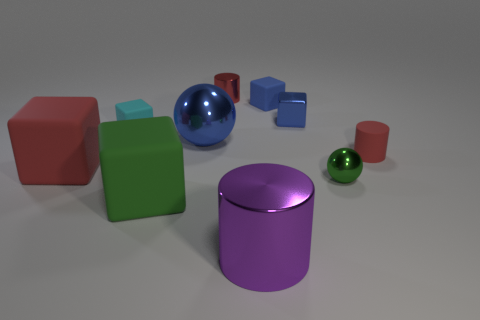There is a red rubber object behind the large rubber object that is on the left side of the green rubber block; what number of small cyan rubber blocks are to the left of it?
Your answer should be very brief. 1. There is a ball that is made of the same material as the small green object; what is its color?
Give a very brief answer. Blue. There is a sphere that is left of the purple cylinder; is its size the same as the tiny red rubber thing?
Offer a very short reply. No. What number of things are large metal cylinders or small cyan things?
Make the answer very short. 2. What material is the small red thing behind the small matte block to the right of the cube that is in front of the green shiny ball?
Ensure brevity in your answer.  Metal. What is the material of the big block to the right of the big red rubber object?
Offer a very short reply. Rubber. Are there any matte blocks of the same size as the matte cylinder?
Keep it short and to the point. Yes. Does the big metallic object behind the green ball have the same color as the small sphere?
Provide a succinct answer. No. What number of yellow objects are either spheres or shiny cubes?
Your answer should be very brief. 0. How many tiny shiny balls are the same color as the large cylinder?
Ensure brevity in your answer.  0. 